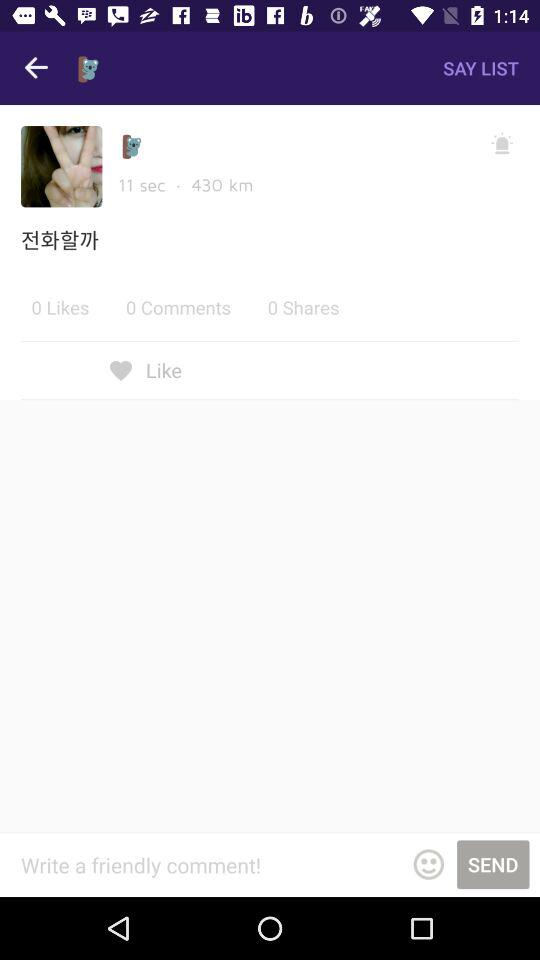What is the given distance? The given distance is 430 km. 